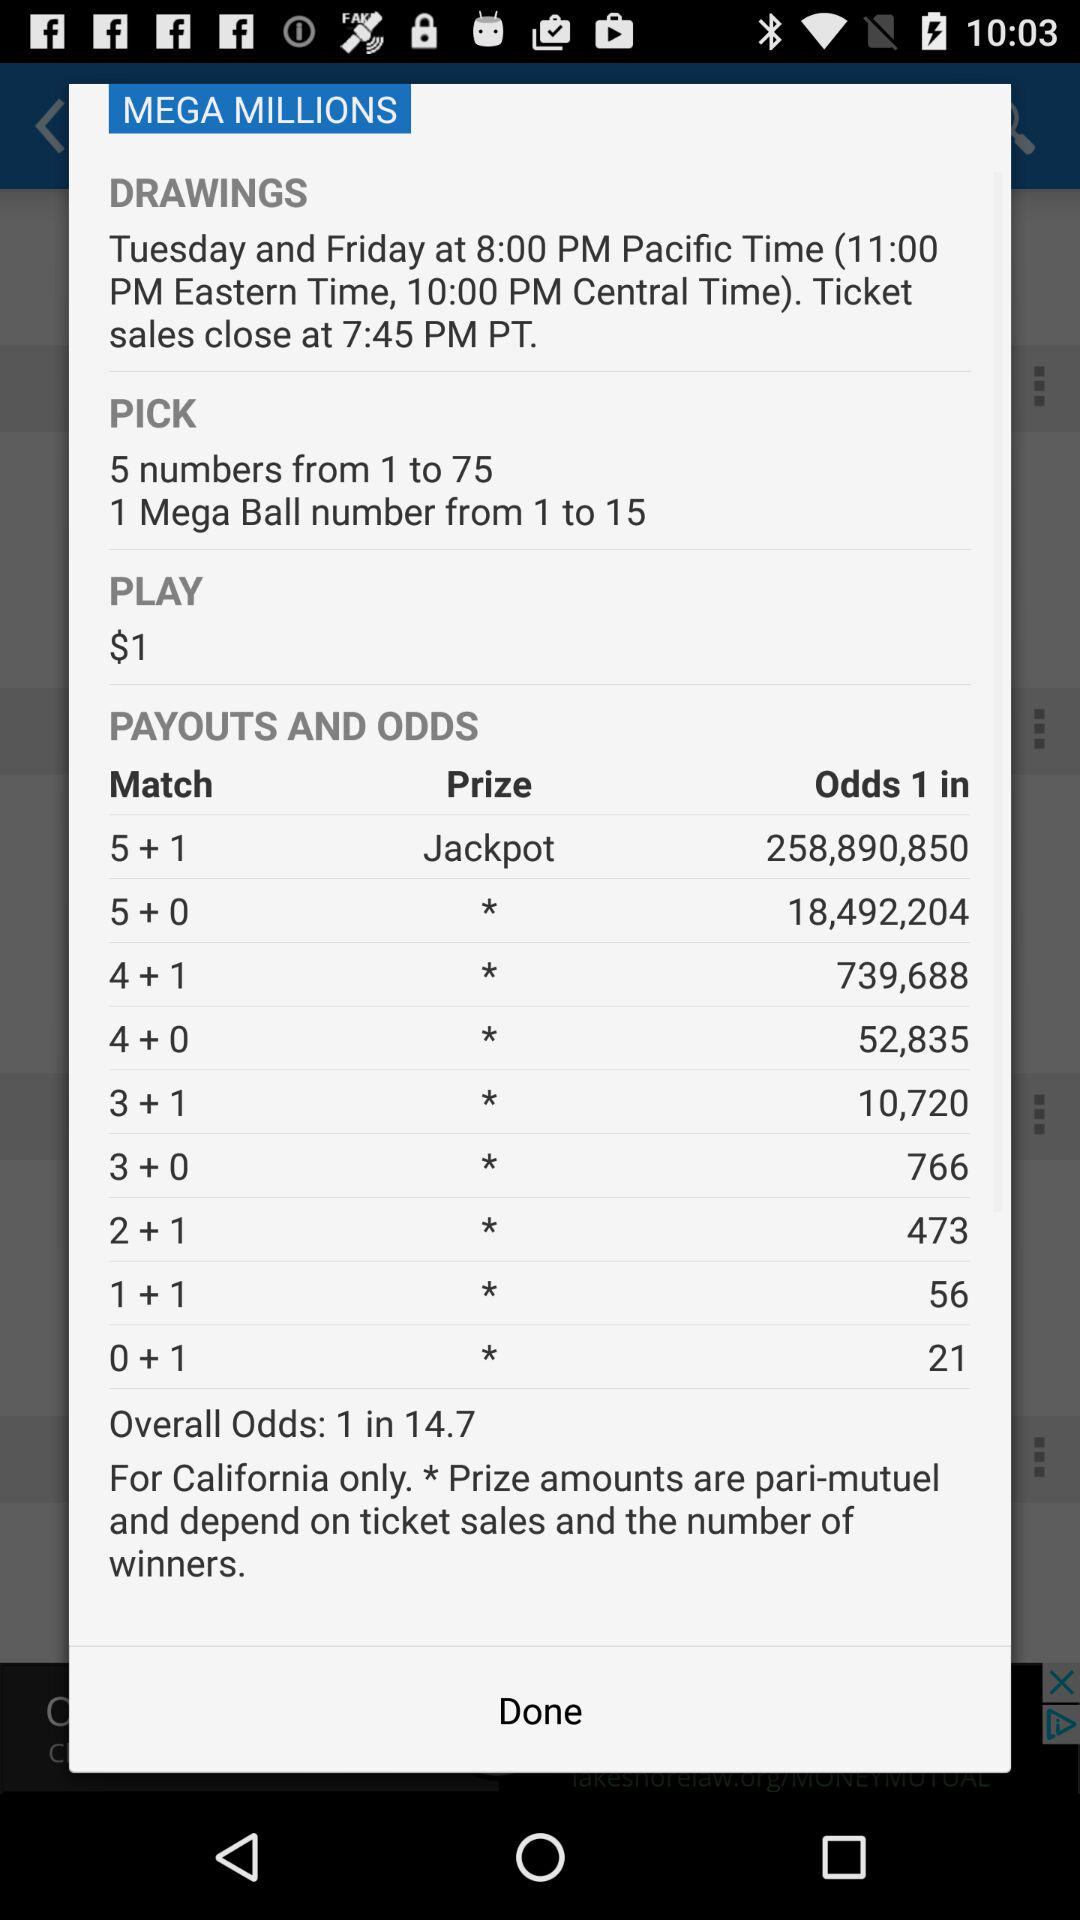What are the overall odds? The overall odds are 1 in 14.7. 